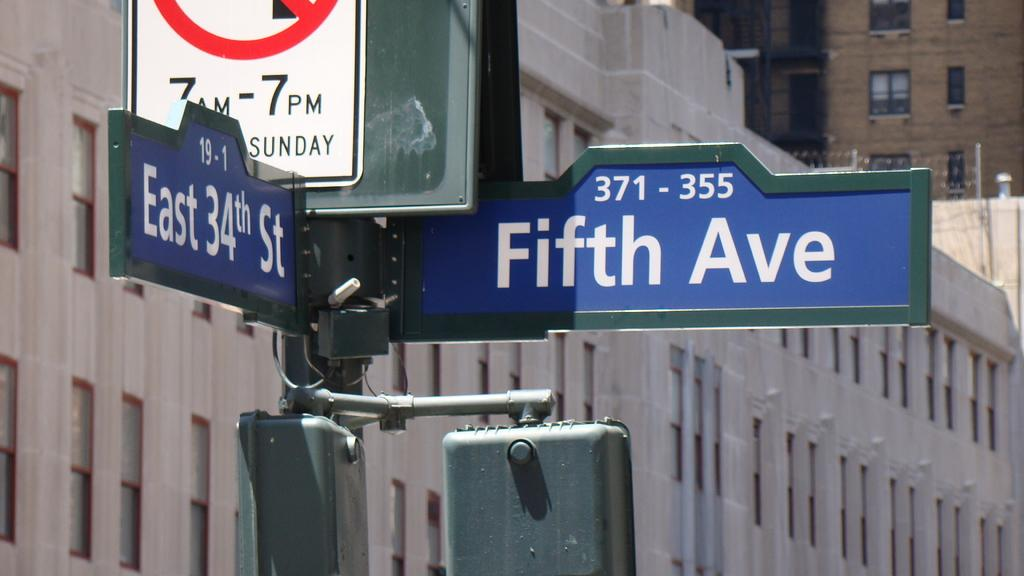<image>
Create a compact narrative representing the image presented. a close up of a sign for Fifth Ave 371-355 